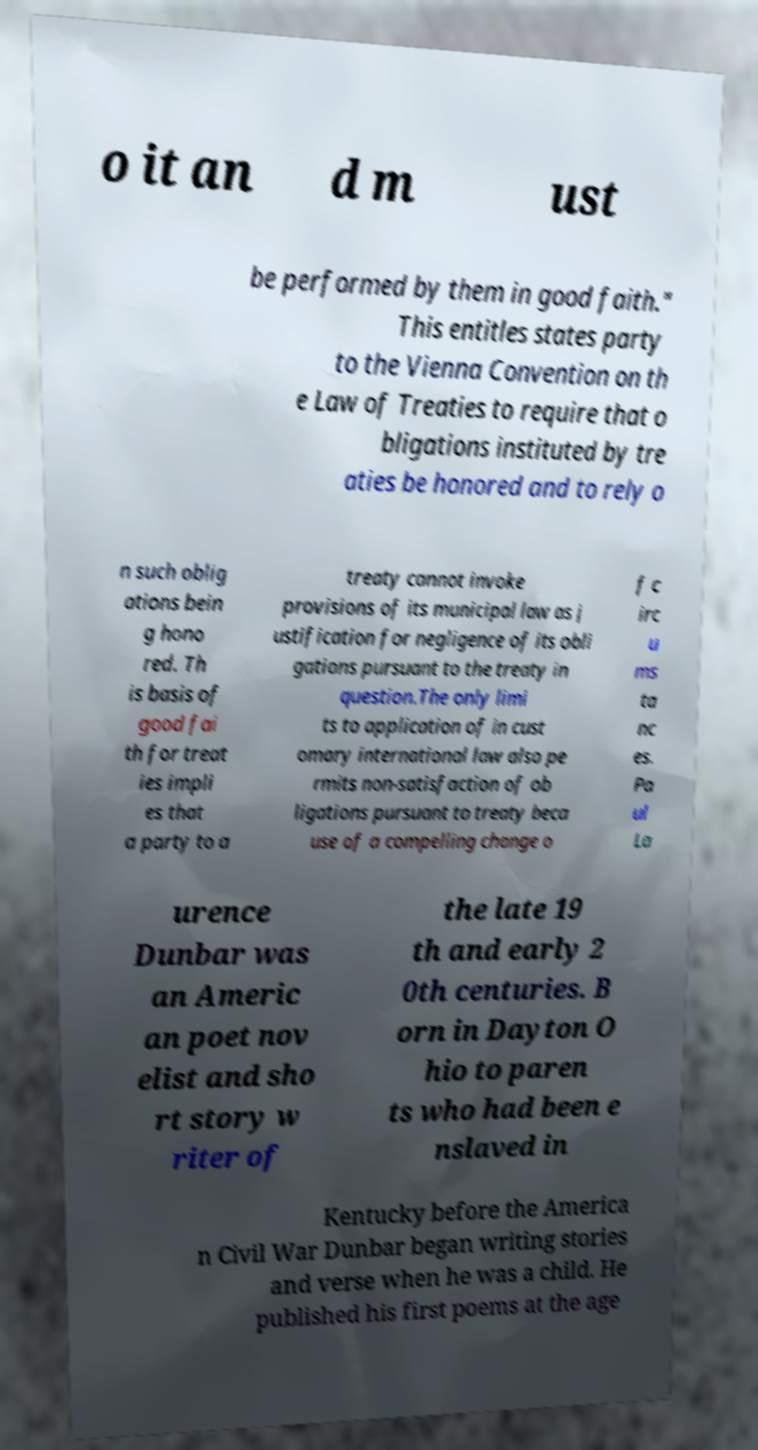Could you assist in decoding the text presented in this image and type it out clearly? o it an d m ust be performed by them in good faith." This entitles states party to the Vienna Convention on th e Law of Treaties to require that o bligations instituted by tre aties be honored and to rely o n such oblig ations bein g hono red. Th is basis of good fai th for treat ies impli es that a party to a treaty cannot invoke provisions of its municipal law as j ustification for negligence of its obli gations pursuant to the treaty in question.The only limi ts to application of in cust omary international law also pe rmits non-satisfaction of ob ligations pursuant to treaty beca use of a compelling change o f c irc u ms ta nc es. Pa ul La urence Dunbar was an Americ an poet nov elist and sho rt story w riter of the late 19 th and early 2 0th centuries. B orn in Dayton O hio to paren ts who had been e nslaved in Kentucky before the America n Civil War Dunbar began writing stories and verse when he was a child. He published his first poems at the age 